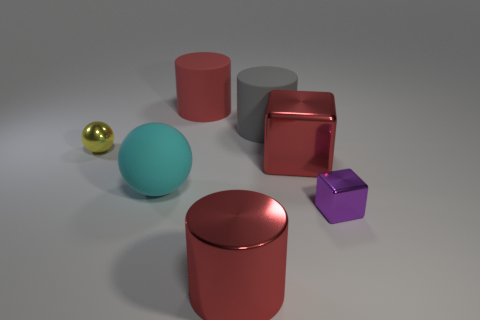How many red cylinders must be subtracted to get 1 red cylinders? 1 Add 1 large cyan things. How many objects exist? 8 Subtract all cylinders. How many objects are left? 4 Add 5 small cubes. How many small cubes are left? 6 Add 3 green objects. How many green objects exist? 3 Subtract 0 gray balls. How many objects are left? 7 Subtract all small blue shiny objects. Subtract all red matte cylinders. How many objects are left? 6 